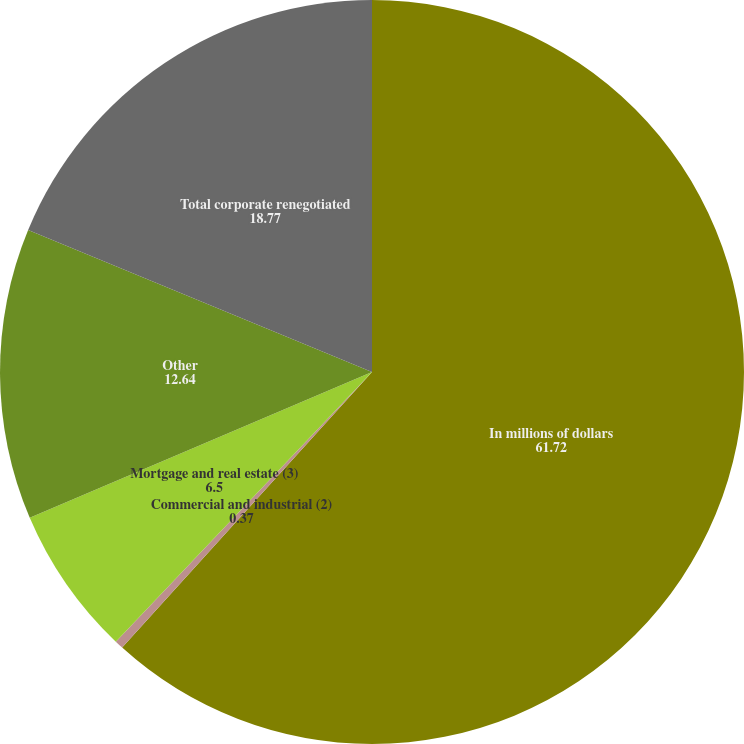Convert chart. <chart><loc_0><loc_0><loc_500><loc_500><pie_chart><fcel>In millions of dollars<fcel>Commercial and industrial (2)<fcel>Mortgage and real estate (3)<fcel>Other<fcel>Total corporate renegotiated<nl><fcel>61.72%<fcel>0.37%<fcel>6.5%<fcel>12.64%<fcel>18.77%<nl></chart> 